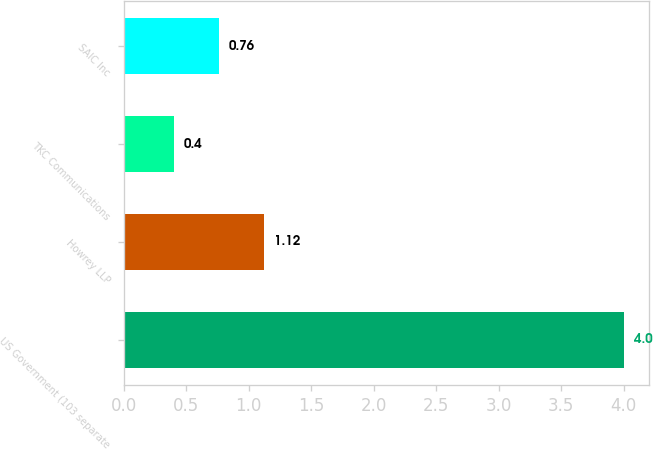Convert chart. <chart><loc_0><loc_0><loc_500><loc_500><bar_chart><fcel>US Government (103 separate<fcel>Howrey LLP<fcel>TKC Communications<fcel>SAIC Inc<nl><fcel>4<fcel>1.12<fcel>0.4<fcel>0.76<nl></chart> 